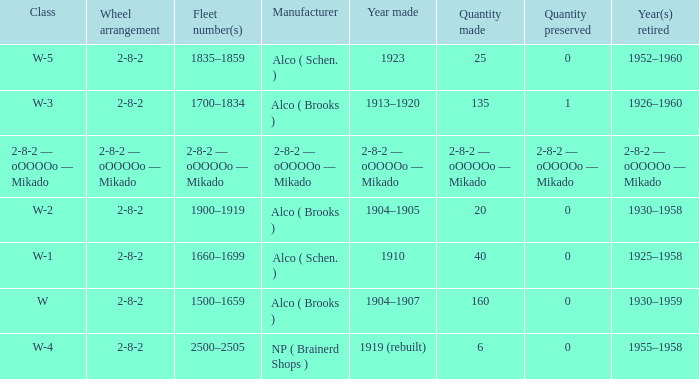Could you parse the entire table? {'header': ['Class', 'Wheel arrangement', 'Fleet number(s)', 'Manufacturer', 'Year made', 'Quantity made', 'Quantity preserved', 'Year(s) retired'], 'rows': [['W-5', '2-8-2', '1835–1859', 'Alco ( Schen. )', '1923', '25', '0', '1952–1960'], ['W-3', '2-8-2', '1700–1834', 'Alco ( Brooks )', '1913–1920', '135', '1', '1926–1960'], ['2-8-2 — oOOOOo — Mikado', '2-8-2 — oOOOOo — Mikado', '2-8-2 — oOOOOo — Mikado', '2-8-2 — oOOOOo — Mikado', '2-8-2 — oOOOOo — Mikado', '2-8-2 — oOOOOo — Mikado', '2-8-2 — oOOOOo — Mikado', '2-8-2 — oOOOOo — Mikado'], ['W-2', '2-8-2', '1900–1919', 'Alco ( Brooks )', '1904–1905', '20', '0', '1930–1958'], ['W-1', '2-8-2', '1660–1699', 'Alco ( Schen. )', '1910', '40', '0', '1925–1958'], ['W', '2-8-2', '1500–1659', 'Alco ( Brooks )', '1904–1907', '160', '0', '1930–1959'], ['W-4', '2-8-2', '2500–2505', 'NP ( Brainerd Shops )', '1919 (rebuilt)', '6', '0', '1955–1958']]} What quantity is maintained in a locomotive with a component of 6? 0.0. 